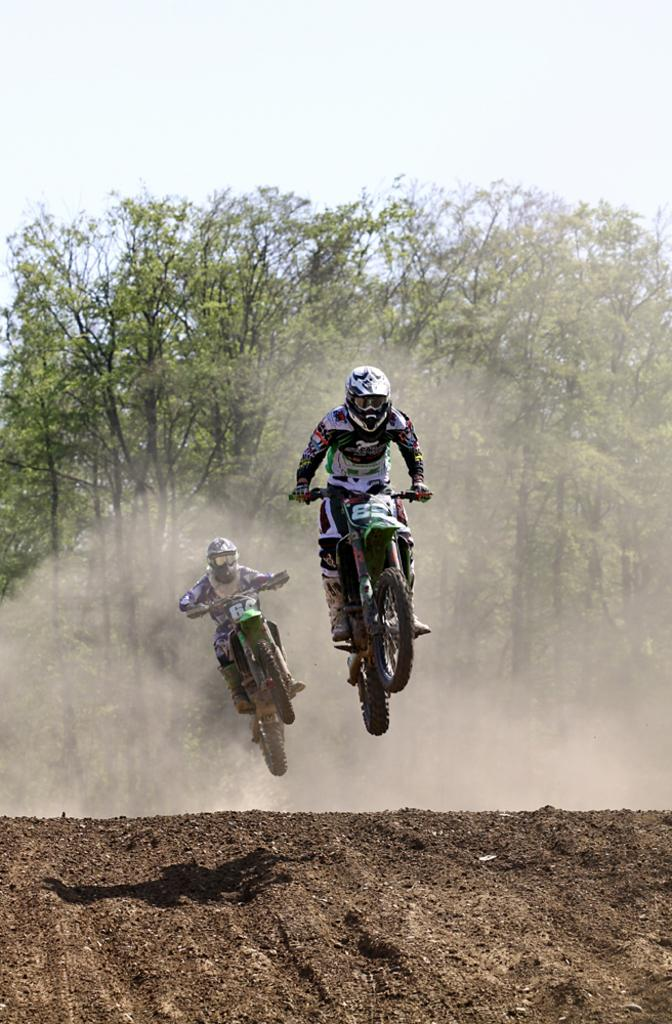What can be seen in the sky in the image? The sky is visible in the image. What type of vegetation is present in the image? There are trees in the image. What is the ground made of in the image? Soil is present in the image. How many people are riding a motorcycle in the image? There are two persons riding a motorcycle in the image. What safety precaution are the persons taking while riding the motorcycle? The persons are wearing helmets. Where is the map placed on the plate in the image? There is no map or plate present in the image. 